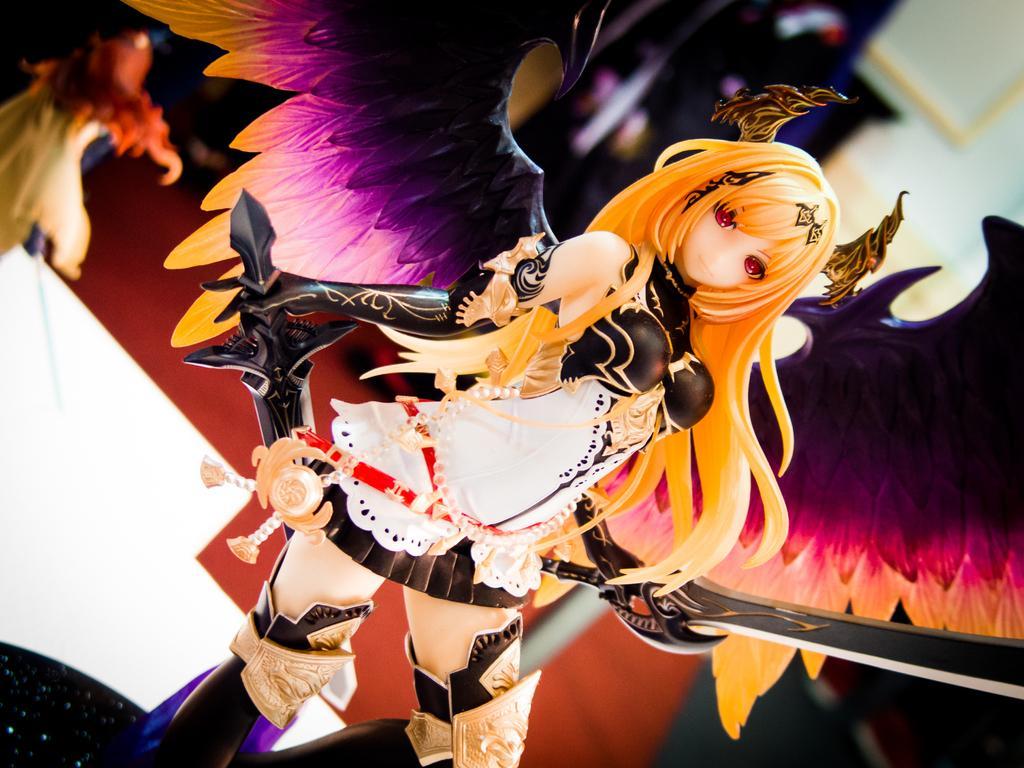Can you describe this image briefly? In this image, we can see a toy on the blur background. This toy contains wings and holding swords. 